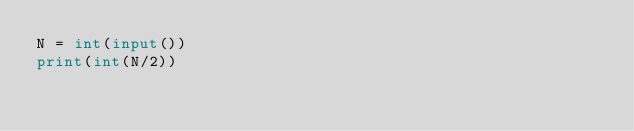Convert code to text. <code><loc_0><loc_0><loc_500><loc_500><_Python_>N = int(input())
print(int(N/2))</code> 